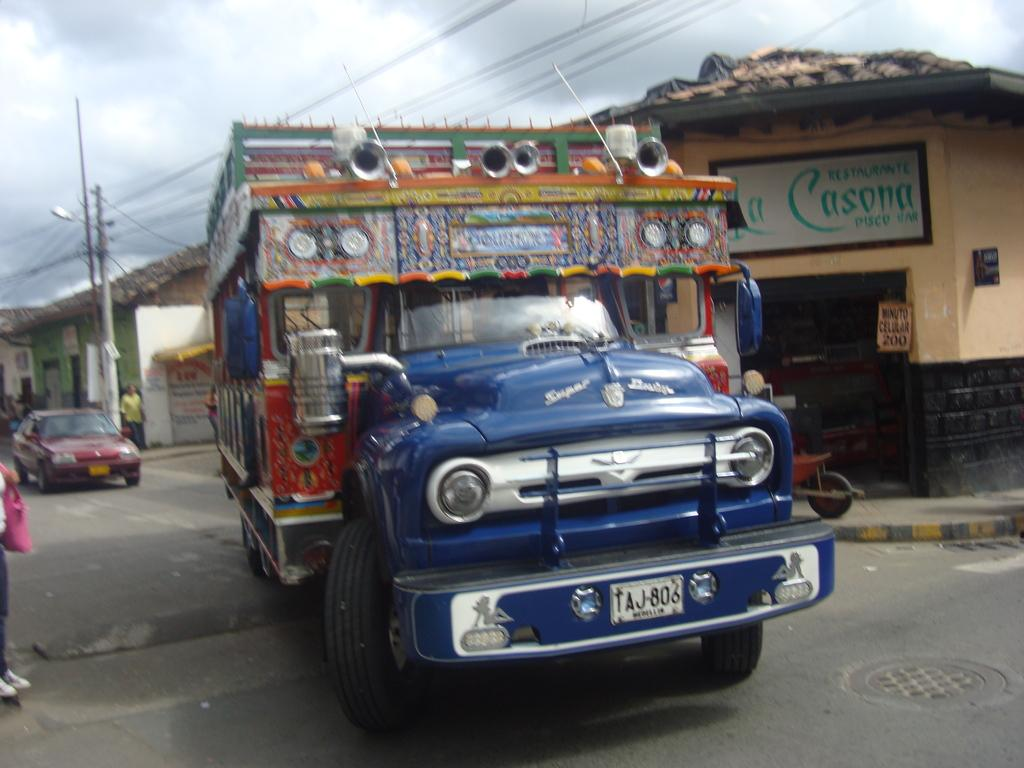What is the main subject in the center of the image? There is a vehicle in the center of the image. Can you describe the people in the image? There are people in the image, but their specific actions or positions are not mentioned in the facts. What can be seen in the background of the image? It appears that there are houses, a vehicle, poles, wires, and the sky visible in the background. What type of soap is being used by the people in the image? There is no mention of soap or any cleaning activity in the image, so it cannot be determined from the facts. What kind of flesh can be seen on the people in the image? The facts do not provide any information about the appearance or condition of the people's flesh, so it cannot be determined from the facts. 